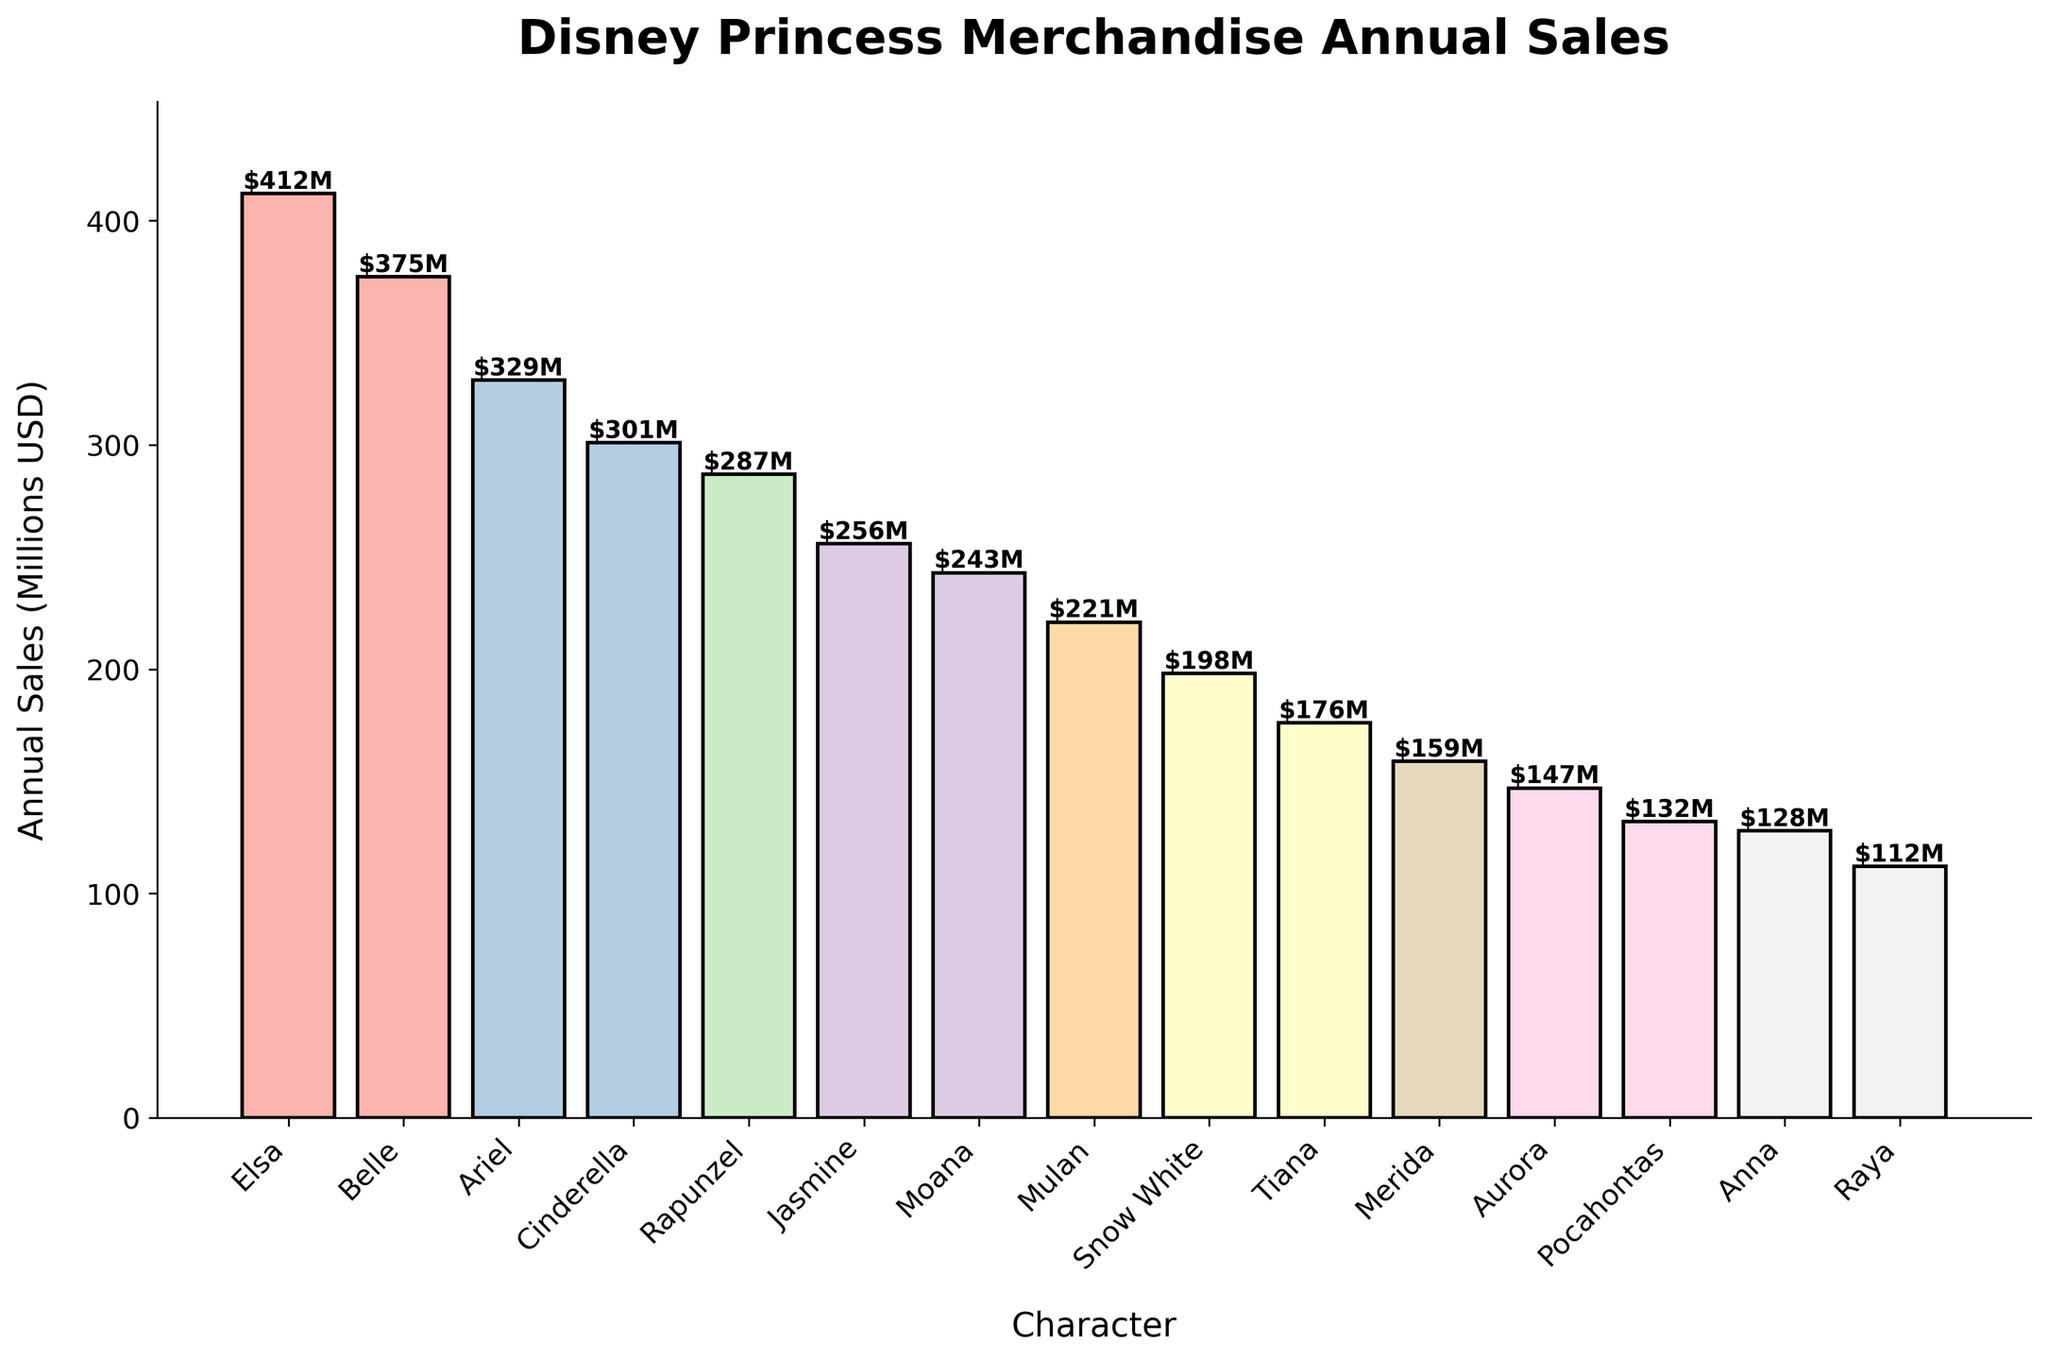Which character has the highest merchandise sales? By visually inspecting the heights of the bars, the tallest bar represents Elsa, indicating she has the highest merchandise sales.
Answer: Elsa Which two characters have the closest annual sales? By comparing the heights of the bars that are close to each other, Belle and Ariel have very similar bar heights, suggesting their sales are close.
Answer: Belle and Ariel How much more does Elsa make in annual sales compared to Anna? Identify the sales for Elsa ($412M) and Anna ($128M). Calculate the difference: $412M - $128M = $284M.
Answer: $284M What is the total annual sales for the top three characters? Add the sales for Elsa ($412M), Belle ($375M), and Ariel ($329M) together: $412M + $375M + $329M = $1,116M.
Answer: $1,116M Which character has slightly more annual sales than Jasmine but less than Rapunzel? By comparing the heights of the bars, Moana has annual sales slightly more than Jasmine ($256M) and less than Rapunzel ($287M).
Answer: Moana Which character has the lowest merchandise sales? The bar with the shortest height represents Raya, indicating she has the lowest sales.
Answer: Raya How much higher are Rapunzel's sales compared to Snow White's? Identify Rapunzel's sales ($287M) and Snow White's sales ($198M). Calculate the difference: $287M - $198M = $89M.
Answer: $89M What is the average annual sales for Ariel, Moana, and Belle? Add their sales together and divide by 3: ($329M + $243M + $375M) / 3 = $315.67M.
Answer: $315.67M Which characters have annual sales between $150M and $200M? By examining the bars, the characters with sales in this range are Snow White ($198M), Tiana ($176M), and Merida ($159M).
Answer: Snow White, Tiana, and Merida What is the combined annual sales of the bottom five characters? Sum the sales of the bottom five characters: Tiana ($176M), Merida ($159M), Aurora ($147M), Pocahontas ($132M), and Anna ($128M): $176M + $159M + $147M + $132M + $128M = $742M.
Answer: $742M Which character's bar is directly next to Belle's on the right? By looking at the bar positioned directly to the right of Belle's, it is identified as Ariel's bar.
Answer: Ariel 